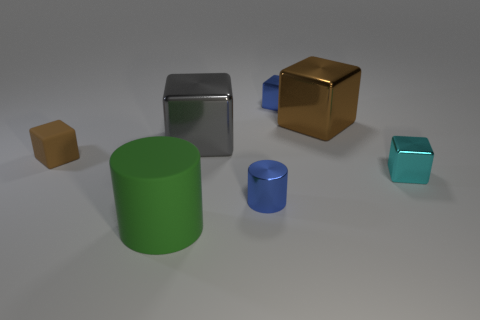Subtract 2 blocks. How many blocks are left? 3 Subtract all gray blocks. How many blocks are left? 4 Subtract all tiny blue shiny cubes. How many cubes are left? 4 Subtract all red blocks. Subtract all cyan balls. How many blocks are left? 5 Add 3 tiny cyan metal cubes. How many objects exist? 10 Subtract all cylinders. How many objects are left? 5 Subtract all green rubber things. Subtract all big things. How many objects are left? 3 Add 6 green matte cylinders. How many green matte cylinders are left? 7 Add 1 tiny green shiny objects. How many tiny green shiny objects exist? 1 Subtract 1 gray blocks. How many objects are left? 6 